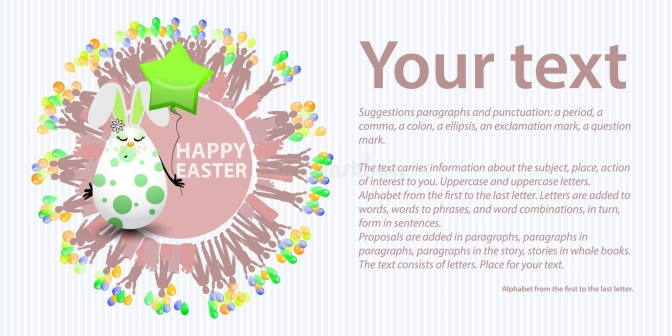Imagine I'm creating a personalized Easter card using this image. What message could I write in the text box? Happy Easter to my dear friends! May your day be filled with joy, love, and a bit of magic, just like our little bunny Pip! Wishing you a delightful and colorful Easter celebration! 